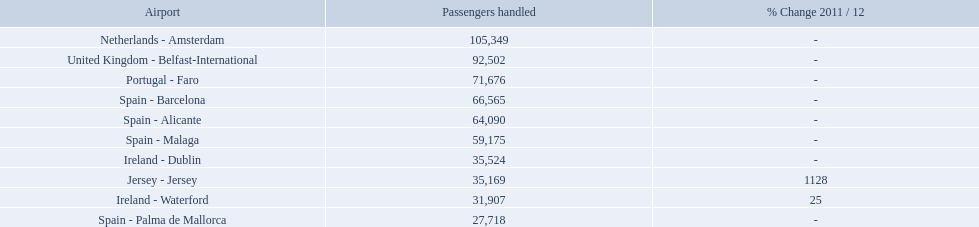What are all the passengers handled values for london southend airport? 105,349, 92,502, 71,676, 66,565, 64,090, 59,175, 35,524, 35,169, 31,907, 27,718. Which are 30,000 or less? 27,718. What airport is this for? Spain - Palma de Mallorca. What are the numbers of passengers handled along the different routes in the airport? 105,349, 92,502, 71,676, 66,565, 64,090, 59,175, 35,524, 35,169, 31,907, 27,718. Of these routes, which handles less than 30,000 passengers? Spain - Palma de Mallorca. What are the names of all the airports? Netherlands - Amsterdam, United Kingdom - Belfast-International, Portugal - Faro, Spain - Barcelona, Spain - Alicante, Spain - Malaga, Ireland - Dublin, Jersey - Jersey, Ireland - Waterford, Spain - Palma de Mallorca. Of these, what are all the passenger counts? 105,349, 92,502, 71,676, 66,565, 64,090, 59,175, 35,524, 35,169, 31,907, 27,718. Of these, which airport had more passengers than the united kingdom? Netherlands - Amsterdam. What are all of the routes out of the london southend airport? Netherlands - Amsterdam, United Kingdom - Belfast-International, Portugal - Faro, Spain - Barcelona, Spain - Alicante, Spain - Malaga, Ireland - Dublin, Jersey - Jersey, Ireland - Waterford, Spain - Palma de Mallorca. How many passengers have traveled to each destination? 105,349, 92,502, 71,676, 66,565, 64,090, 59,175, 35,524, 35,169, 31,907, 27,718. And which destination has been the most popular to passengers? Netherlands - Amsterdam. 